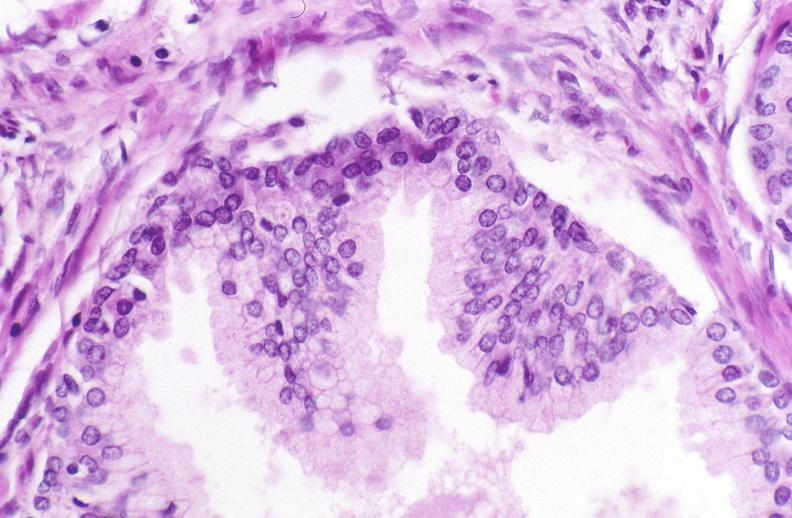does this image show prostate, benign prostatic hyperplasia?
Answer the question using a single word or phrase. Yes 